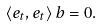Convert formula to latex. <formula><loc_0><loc_0><loc_500><loc_500>\langle e _ { t } , e _ { t } \rangle \, b = 0 .</formula> 